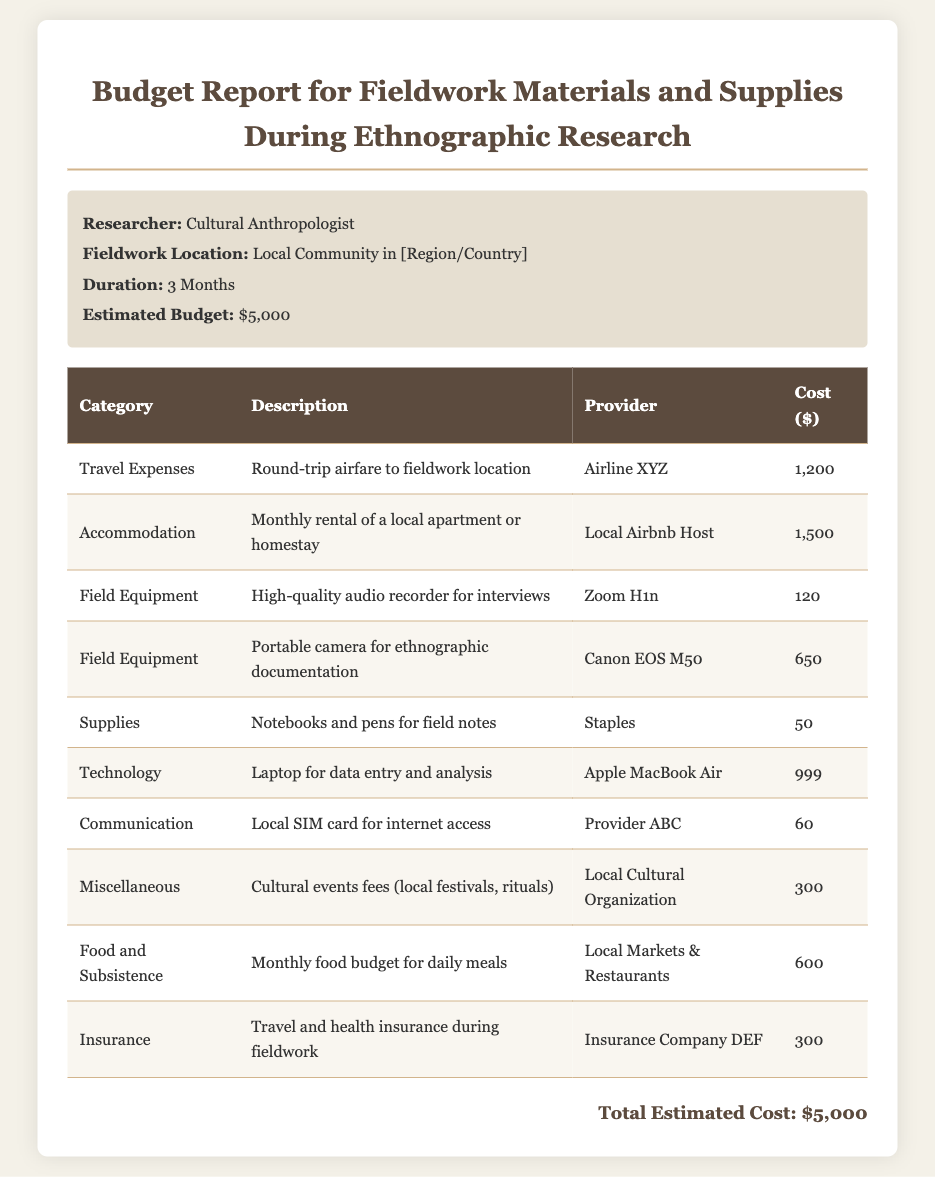What is the total estimated budget? The total estimated budget is indicated at the bottom of the document summary.
Answer: $5,000 Who is the researcher listed in the document? The document specifies the role of the researcher in the information section.
Answer: Cultural Anthropologist What is the cost of the local apartment or homestay? The cost is outlined under the Accommodation category in the table.
Answer: 1,500 How much is allocated for the high-quality audio recorder? The cost is specified in the Field Equipment section for the audio recorder.
Answer: 120 What type of laptop is included in the budget? The document details the specific type of laptop under the Technology category.
Answer: Apple MacBook Air What expenses are covered under Miscellaneous? The document lists a specific item related to local cultural events under the Miscellaneous category.
Answer: Cultural events fees (local festivals, rituals) What is the provider for the local SIM card? The document provides the name of the provider in the Communication section.
Answer: Provider ABC Which airline is mentioned for travel expenses? The document includes the name of the airline in the Travel Expenses category.
Answer: Airline XYZ What is the estimated monthly food budget? The document indicates the specific budget allocated for food under the Food and Subsistence category.
Answer: 600 